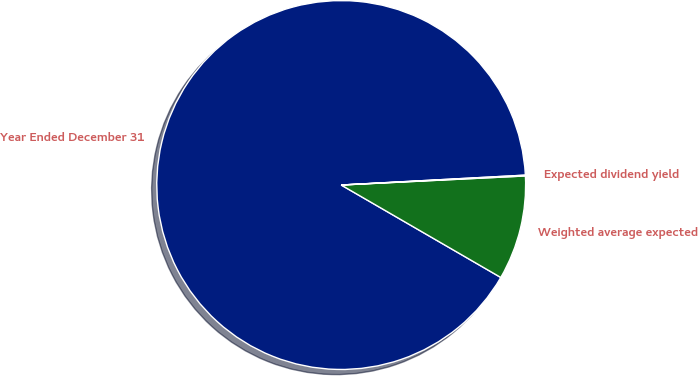Convert chart to OTSL. <chart><loc_0><loc_0><loc_500><loc_500><pie_chart><fcel>Year Ended December 31<fcel>Weighted average expected<fcel>Expected dividend yield<nl><fcel>90.79%<fcel>9.14%<fcel>0.07%<nl></chart> 